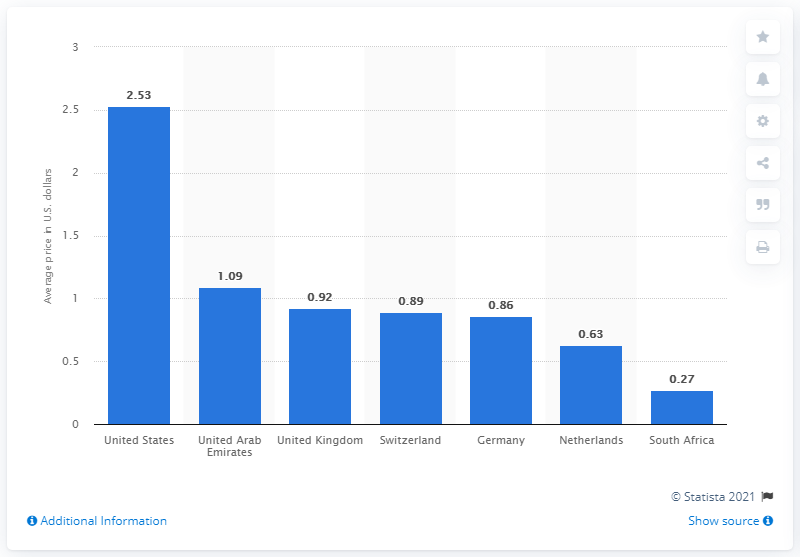Draw attention to some important aspects in this diagram. In 2017, the average price of factor VIII in the United States was 2.53. 